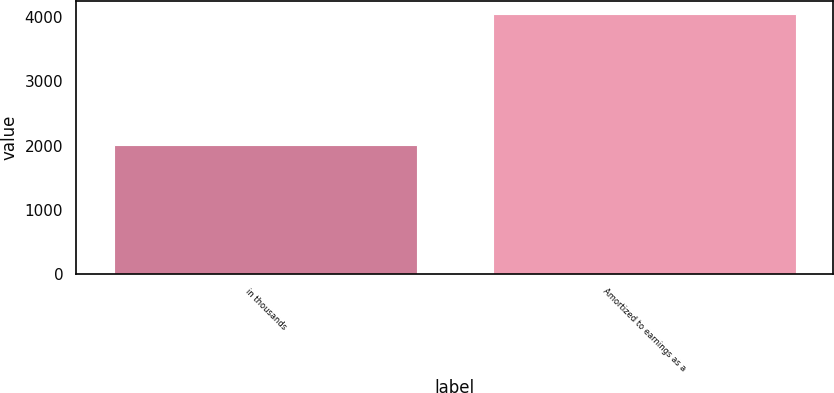Convert chart. <chart><loc_0><loc_0><loc_500><loc_500><bar_chart><fcel>in thousands<fcel>Amortized to earnings as a<nl><fcel>2012<fcel>4052<nl></chart> 